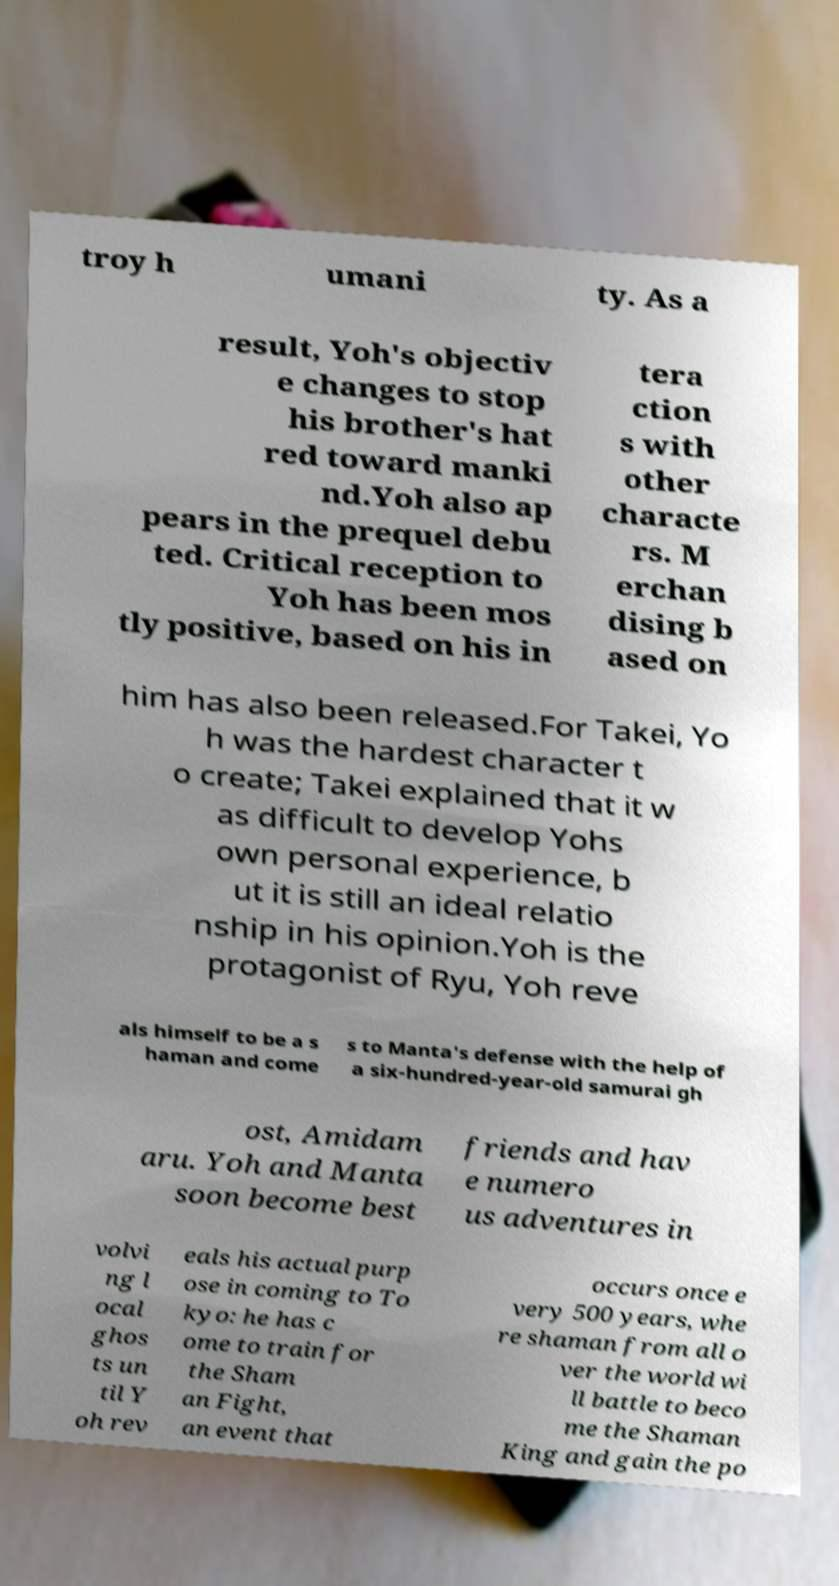Can you read and provide the text displayed in the image?This photo seems to have some interesting text. Can you extract and type it out for me? troy h umani ty. As a result, Yoh's objectiv e changes to stop his brother's hat red toward manki nd.Yoh also ap pears in the prequel debu ted. Critical reception to Yoh has been mos tly positive, based on his in tera ction s with other characte rs. M erchan dising b ased on him has also been released.For Takei, Yo h was the hardest character t o create; Takei explained that it w as difficult to develop Yohs own personal experience, b ut it is still an ideal relatio nship in his opinion.Yoh is the protagonist of Ryu, Yoh reve als himself to be a s haman and come s to Manta's defense with the help of a six-hundred-year-old samurai gh ost, Amidam aru. Yoh and Manta soon become best friends and hav e numero us adventures in volvi ng l ocal ghos ts un til Y oh rev eals his actual purp ose in coming to To kyo: he has c ome to train for the Sham an Fight, an event that occurs once e very 500 years, whe re shaman from all o ver the world wi ll battle to beco me the Shaman King and gain the po 